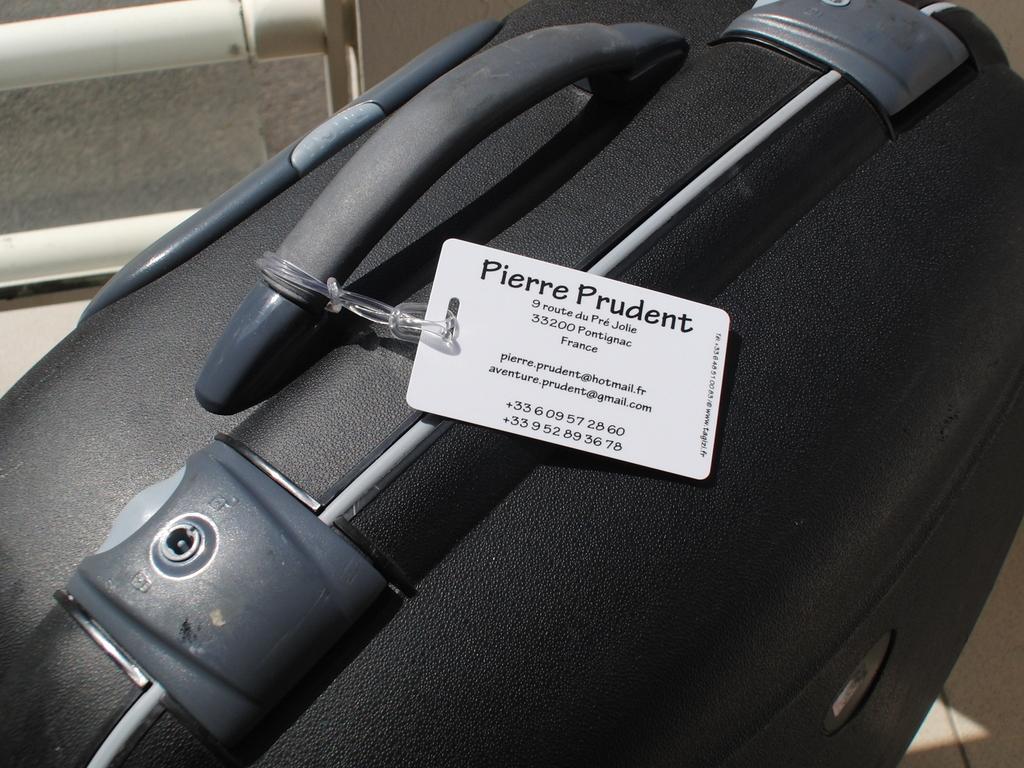Could you give a brief overview of what you see in this image? In this image we can see a nice suitcase with lock system and a price tag to the handle. 